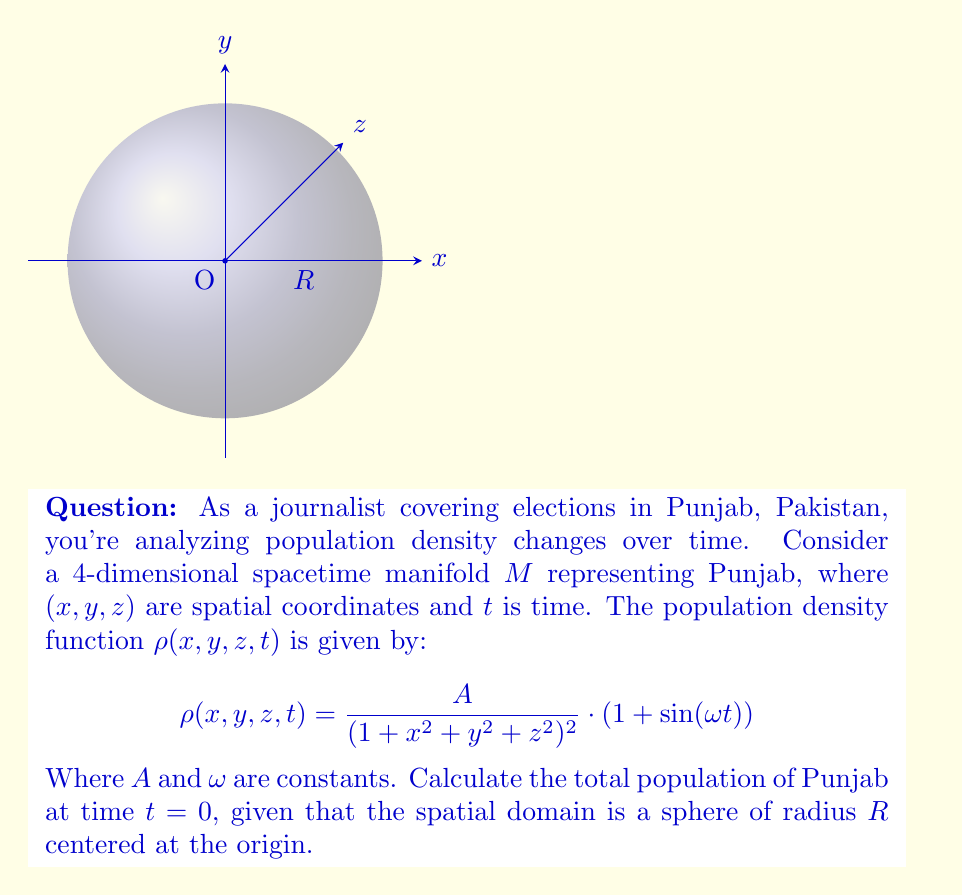Solve this math problem. Let's approach this step-by-step:

1) At $t=0$, the population density function simplifies to:
   $$\rho(x, y, z, 0) = \frac{A}{(1 + x^2 + y^2 + z^2)^2}$$

2) To find the total population, we need to integrate this function over the given spatial domain:
   $$P = \iiint_V \rho(x, y, z, 0) dV$$

3) Given the spherical symmetry of both the domain and the function, it's best to use spherical coordinates:
   $x = r\sin\theta\cos\phi$, $y = r\sin\theta\sin\phi$, $z = r\cos\theta$
   
4) The volume element in spherical coordinates is:
   $$dV = r^2 \sin\theta ~dr ~d\theta ~d\phi$$

5) The limits of integration are:
   $0 \leq r \leq R$, $0 \leq \theta \leq \pi$, $0 \leq \phi \leq 2\pi$

6) Substituting into the integral:
   $$P = \int_0^{2\pi} \int_0^{\pi} \int_0^R \frac{A}{(1 + r^2)^2} r^2 \sin\theta ~dr ~d\theta ~d\phi$$

7) Simplify by integrating $\phi$ and $\theta$:
   $$P = 4\pi A \int_0^R \frac{r^2}{(1 + r^2)^2} ~dr$$

8) Use substitution $u = 1 + r^2$, $du = 2r~dr$:
   $$P = 2\pi A \int_1^{1+R^2} \frac{u-1}{u^2} ~du$$

9) Integrate:
   $$P = 2\pi A \left[-\frac{1}{u} - \ln(u)\right]_1^{1+R^2}$$

10) Simplify:
    $$P = 2\pi A \left(\frac{R^2}{1+R^2} + \ln(1+R^2)\right)$$

This is the final expression for the total population at $t=0$.
Answer: $2\pi A \left(\frac{R^2}{1+R^2} + \ln(1+R^2)\right)$ 